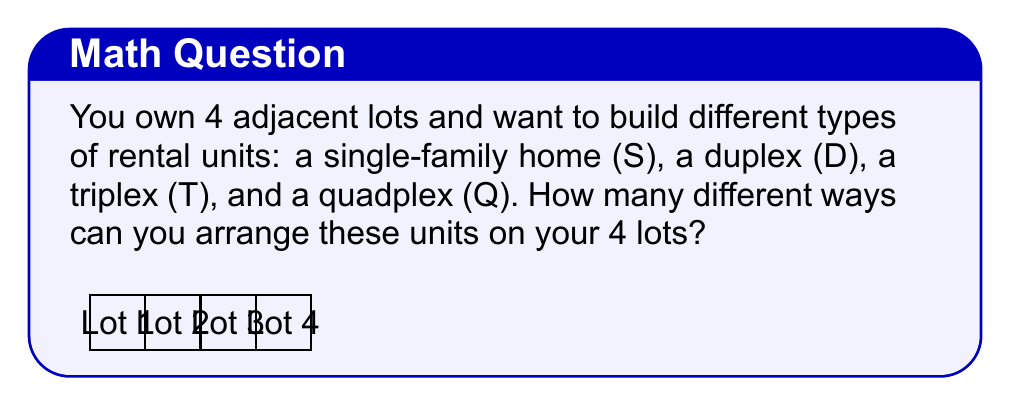Provide a solution to this math problem. Let's approach this step-by-step:

1) This is a permutation problem. We have 4 different types of units (S, D, T, Q) and 4 positions (lots) to arrange them in.

2) The formula for permutations of n distinct objects is:

   $$P(n) = n!$$

3) In this case, n = 4, so we have:

   $$P(4) = 4!$$

4) Let's calculate 4!:
   
   $$4! = 4 \times 3 \times 2 \times 1 = 24$$

5) Therefore, there are 24 different ways to arrange these 4 types of rental units on the 4 adjacent lots.

6) To visualize this, we can think of it as:
   - 4 choices for the first lot
   - 3 remaining choices for the second lot
   - 2 remaining choices for the third lot
   - Only 1 choice left for the last lot

   $$4 \times 3 \times 2 \times 1 = 24$$
Answer: 24 